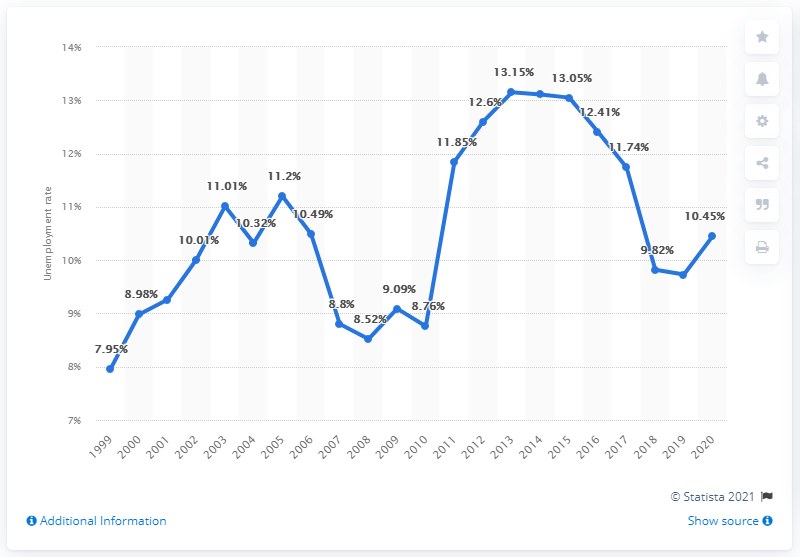Indicate a few pertinent items in this graphic. The unemployment rate in Egypt in 2020 was 10.45%. 